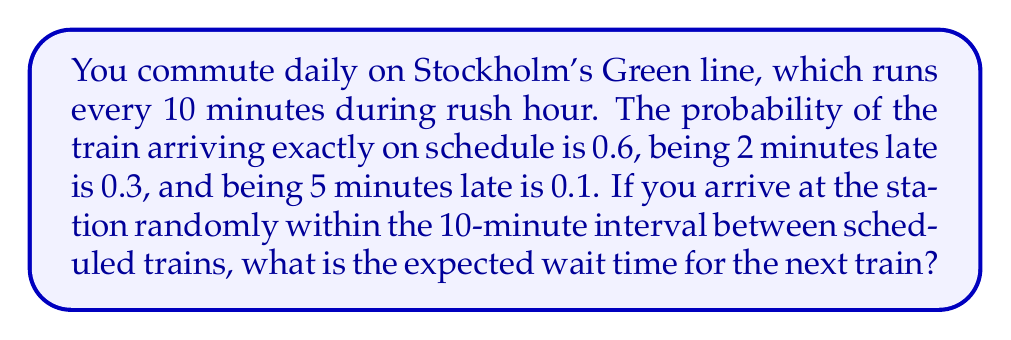Could you help me with this problem? Let's approach this step-by-step:

1) First, we need to calculate the expected delay of the train:
   $E(\text{delay}) = 0 \cdot 0.6 + 2 \cdot 0.3 + 5 \cdot 0.1 = 0.6 + 0.5 = 1.1$ minutes

2) Now, let's consider your arrival time. Since you arrive randomly within the 10-minute interval, your arrival time is uniformly distributed over [0, 10).

3) For a uniform distribution over [0, 10), the expected value of your arrival time after the previous scheduled train is:
   $E(\text{arrival}) = \frac{0 + 10}{2} = 5$ minutes

4) The expected wait time depends on whether you arrive before or after the (potentially delayed) train:

   a) If you arrive before the train, you wait for the train.
   b) If you arrive after the train, you wait for the next train.

5) The probability of arriving before the train is:
   $P(\text{arrive before}) = \frac{10 + 1.1}{10} = 1.11$
   However, this is greater than 1, so we cap it at 1.

6) Therefore, the expected wait time is:

   $E(\text{wait}) = 1 \cdot E(\text{wait|before}) + 0 \cdot E(\text{wait|after})$

   $E(\text{wait|before}) = E(\text{train arrival}) - E(\text{your arrival})$
                          $= (10 + 1.1) - 5 = 6.1$ minutes

7) Thus, the expected wait time is 6.1 minutes.
Answer: 6.1 minutes 